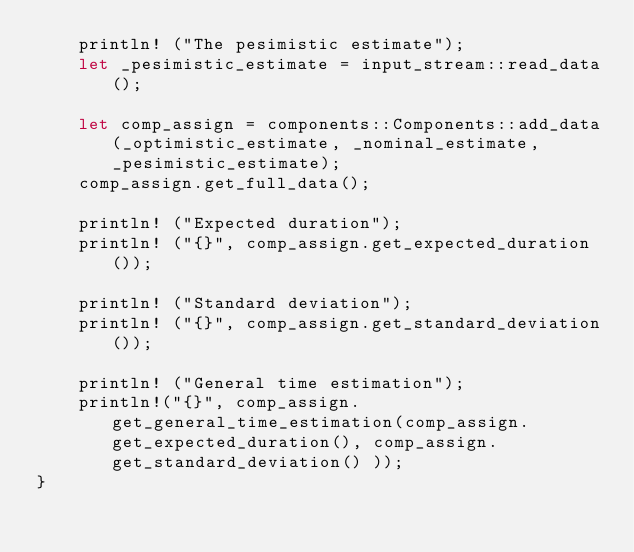<code> <loc_0><loc_0><loc_500><loc_500><_Rust_>    println! ("The pesimistic estimate");
    let _pesimistic_estimate = input_stream::read_data();

    let comp_assign = components::Components::add_data(_optimistic_estimate, _nominal_estimate, _pesimistic_estimate);
    comp_assign.get_full_data();

    println! ("Expected duration");
    println! ("{}", comp_assign.get_expected_duration());

    println! ("Standard deviation");
    println! ("{}", comp_assign.get_standard_deviation());

    println! ("General time estimation");
    println!("{}", comp_assign.get_general_time_estimation(comp_assign.get_expected_duration(), comp_assign.get_standard_deviation() ));
}
</code> 